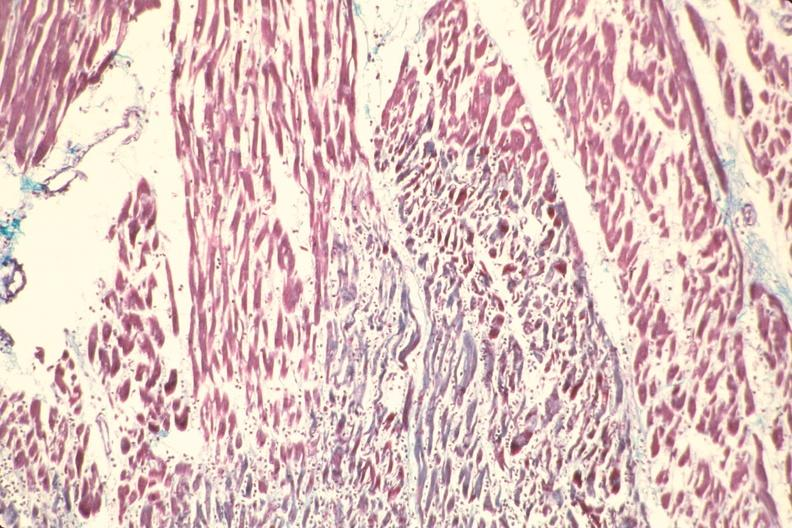s marked present?
Answer the question using a single word or phrase. No 